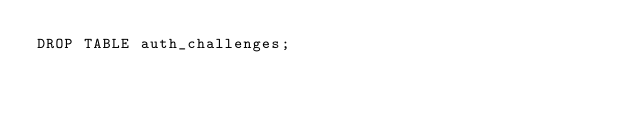<code> <loc_0><loc_0><loc_500><loc_500><_SQL_>DROP TABLE auth_challenges;
</code> 